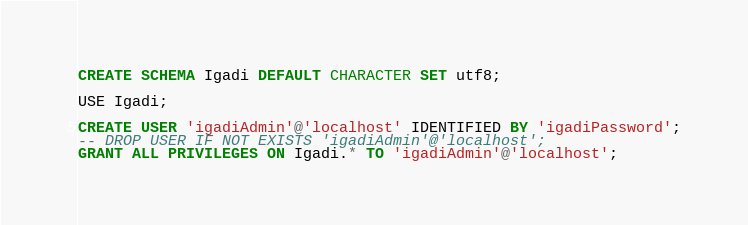<code> <loc_0><loc_0><loc_500><loc_500><_SQL_>
CREATE SCHEMA Igadi DEFAULT CHARACTER SET utf8;

USE Igadi;

CREATE USER 'igadiAdmin'@'localhost' IDENTIFIED BY 'igadiPassword';
-- DROP USER IF NOT EXISTS 'igadiAdmin'@'localhost';
GRANT ALL PRIVILEGES ON Igadi.* TO 'igadiAdmin'@'localhost';
</code> 